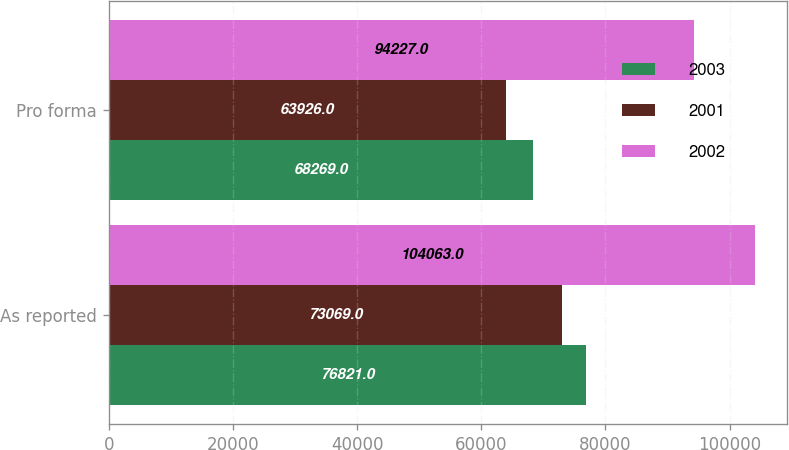Convert chart to OTSL. <chart><loc_0><loc_0><loc_500><loc_500><stacked_bar_chart><ecel><fcel>As reported<fcel>Pro forma<nl><fcel>2003<fcel>76821<fcel>68269<nl><fcel>2001<fcel>73069<fcel>63926<nl><fcel>2002<fcel>104063<fcel>94227<nl></chart> 